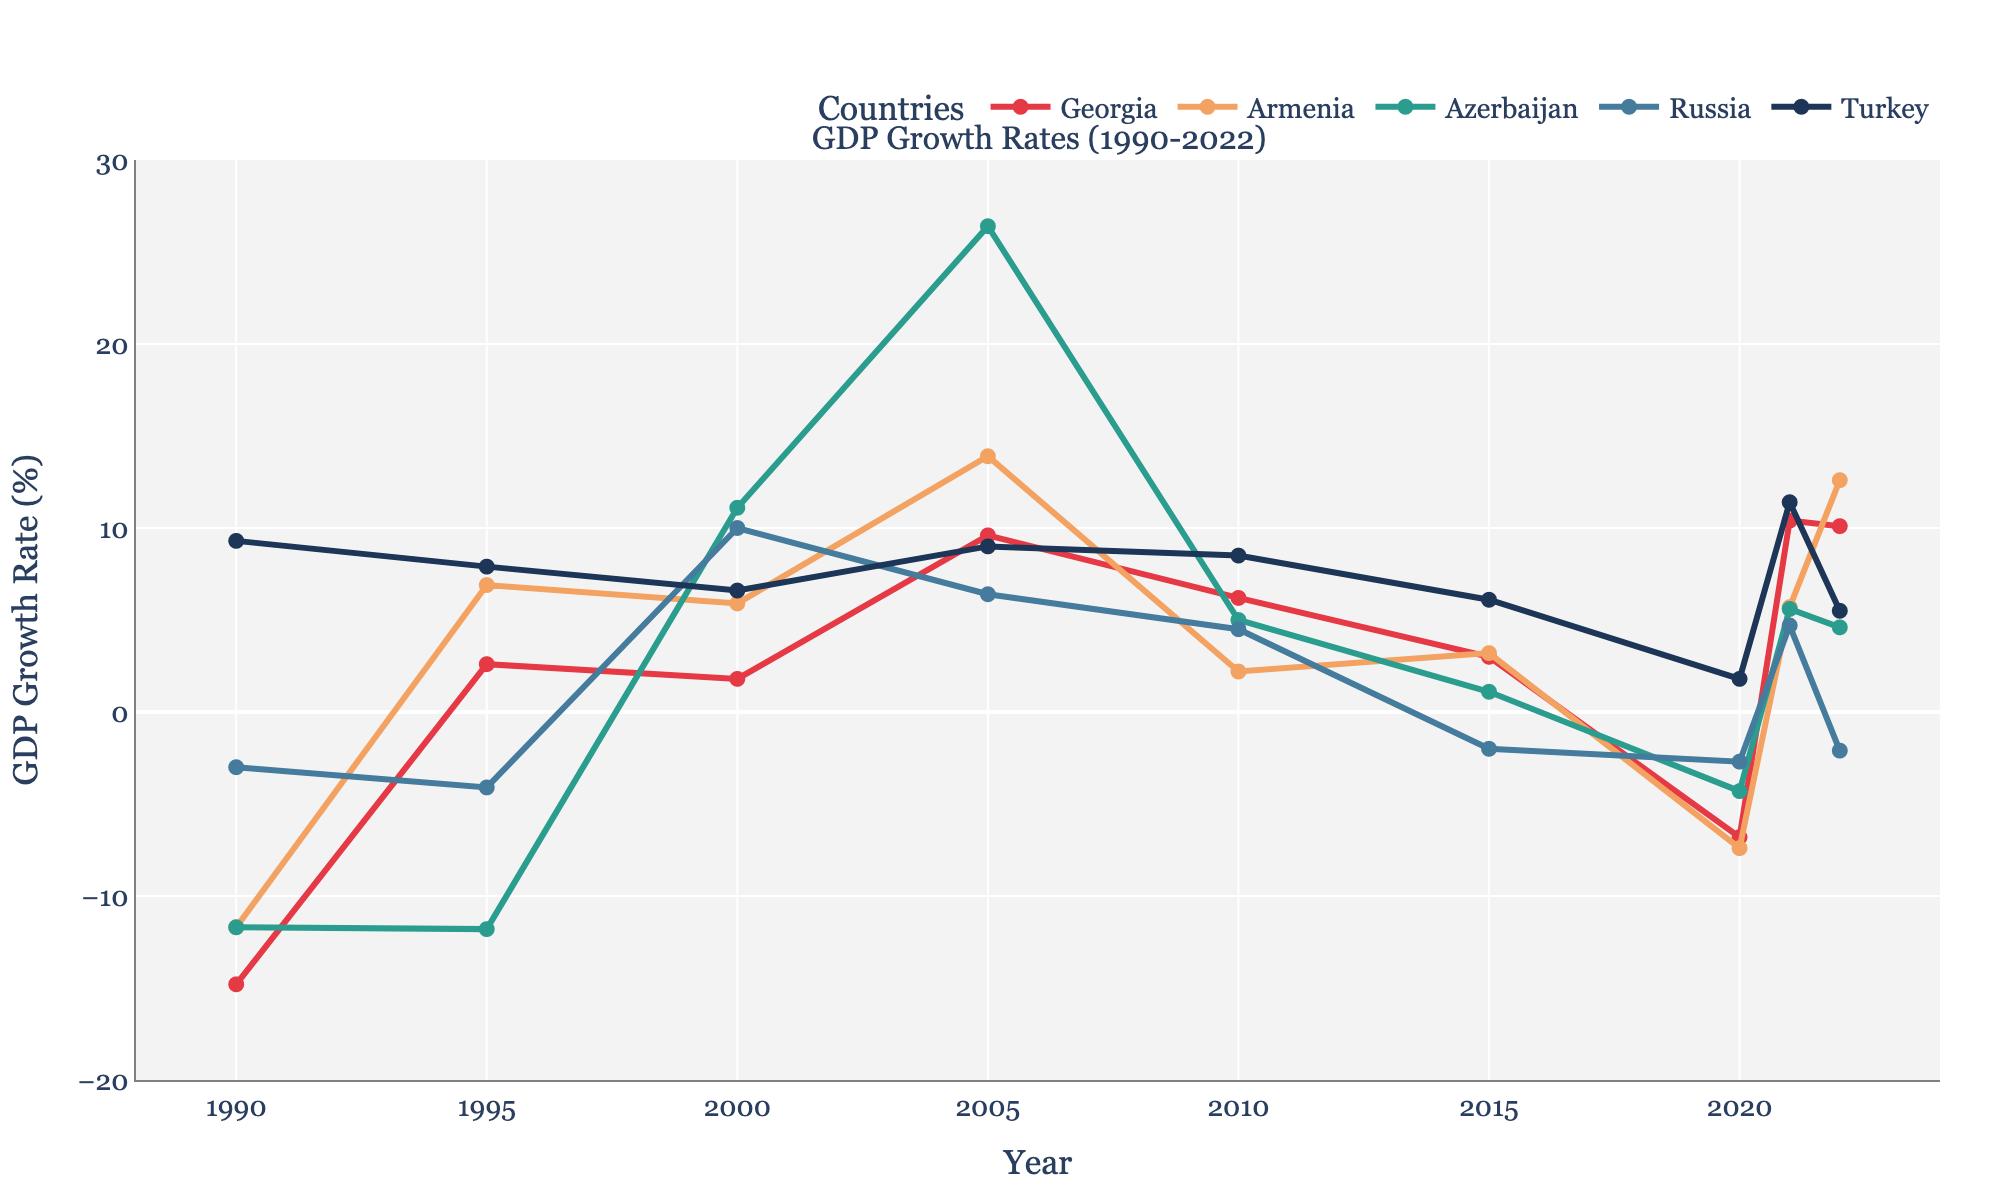What was the GDP growth rate of Georgia in 2021? Georgia's line is marked with red, and by locating 2021 on the x-axis, we see the corresponding y-value, which represents the GDP growth rate
Answer: 10.4% Which country had the highest GDP growth rate in 2022? By observing the highest marker in the plot for the year 2022, it corresponds to Armenia, represented by the orange line
Answer: Armenia How did Georgia's GDP growth rate compare to Russia's in 2020? Locate the year 2020 on the x-axis and compare the values of the red line (Georgia) and the blue line (Russia). Georgia's rate was lower
Answer: Georgia: -6.8%, Russia: -2.7% What is the average GDP growth rate of Turkey from 2000 to 2010? Calculate the average by adding Turkey's GDP growth rates for 2000, 2005, and 2010, then divide by 3: (6.6 + 9.0 + 8.5) / 3
Answer: 8.03% Which countries experienced negative GDP growth rates in 2020? Locate 2020 on the x-axis and observe which lines are below the zero mark. Georgia, Armenia, Azerbaijan, and Russia had negative rates
Answer: Georgia, Armenia, Azerbaijan, Russia Between 1995 and 2005, which country witnessed the most significant increase in GDP growth rate? Calculate the difference for each country between 1995 and 2005, then identify the largest increase: Georgia (9.6 - 2.6 = 7.0), Armenia (13.9 - 6.9 = 7.0), Azerbaijan (26.4 - (-11.8) = 38.2), etc. Azerbaijan has the highest increase
Answer: Azerbaijan In what years did Azerbaijan experience double-digit GDP growth rates? Identify the years where the line representing Azerbaijan (green) lies above the 10% mark: 2000, 2005
Answer: 2000, 2005 Which country had more stable GDP growth rates from 1990 to 2022: Georgia or Turkey? Examine the consistency of the red line (Georgia) and the dark blue line (Turkey). Turkey shows less fluctuation over the years
Answer: Turkey What was the maximum GDP growth rate achieved by Armenia, and in which year? Look for the highest point on the orange line and note the corresponding year on the x-axis
Answer: 13.9% in 2005 